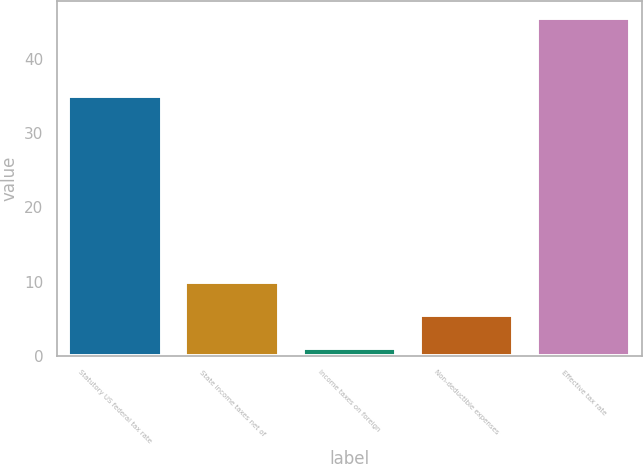Convert chart. <chart><loc_0><loc_0><loc_500><loc_500><bar_chart><fcel>Statutory US federal tax rate<fcel>State income taxes net of<fcel>Income taxes on foreign<fcel>Non-deductible expenses<fcel>Effective tax rate<nl><fcel>35<fcel>9.9<fcel>1<fcel>5.45<fcel>45.5<nl></chart> 